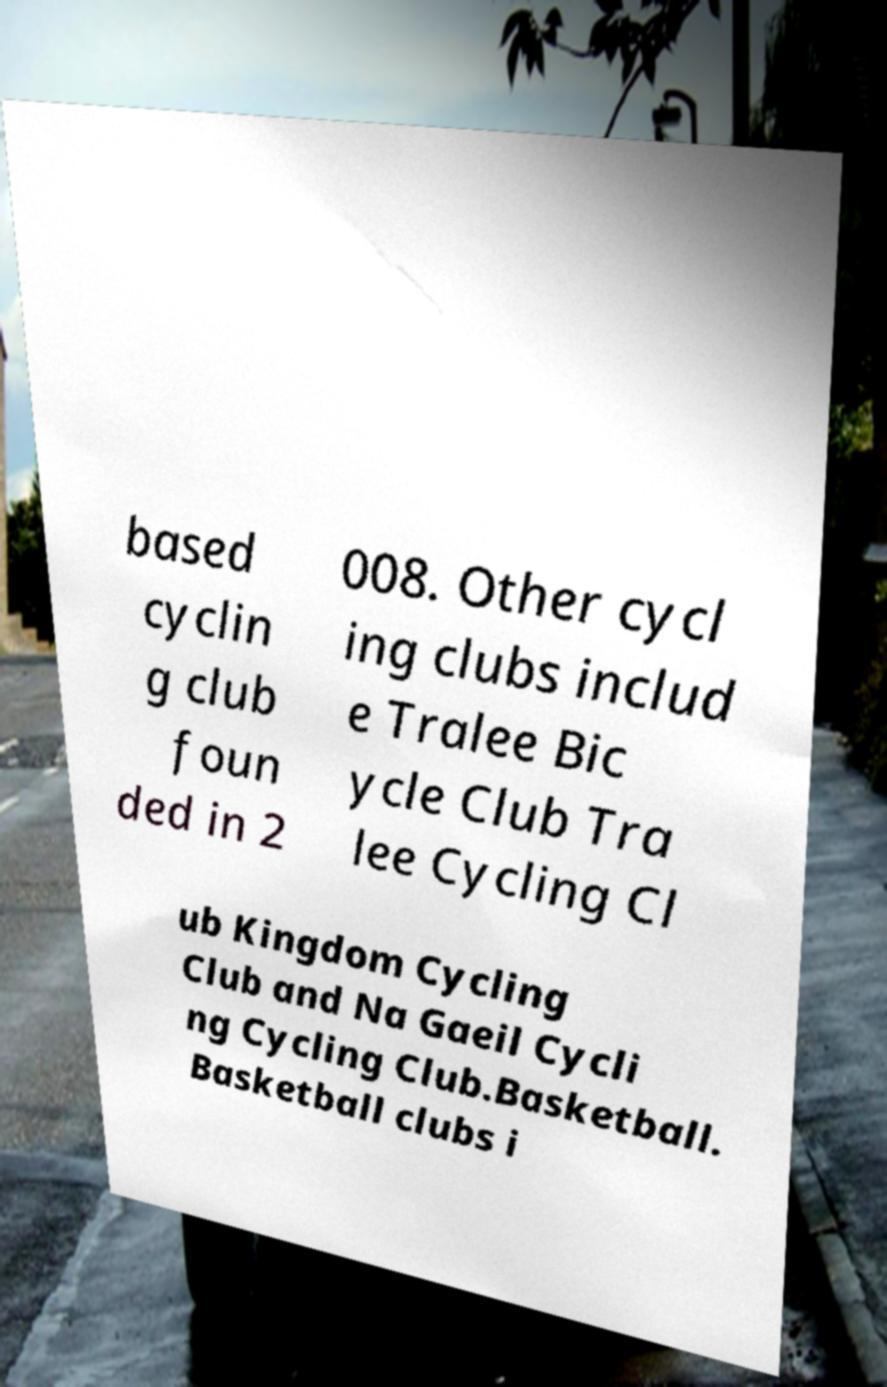Could you assist in decoding the text presented in this image and type it out clearly? based cyclin g club foun ded in 2 008. Other cycl ing clubs includ e Tralee Bic ycle Club Tra lee Cycling Cl ub Kingdom Cycling Club and Na Gaeil Cycli ng Cycling Club.Basketball. Basketball clubs i 